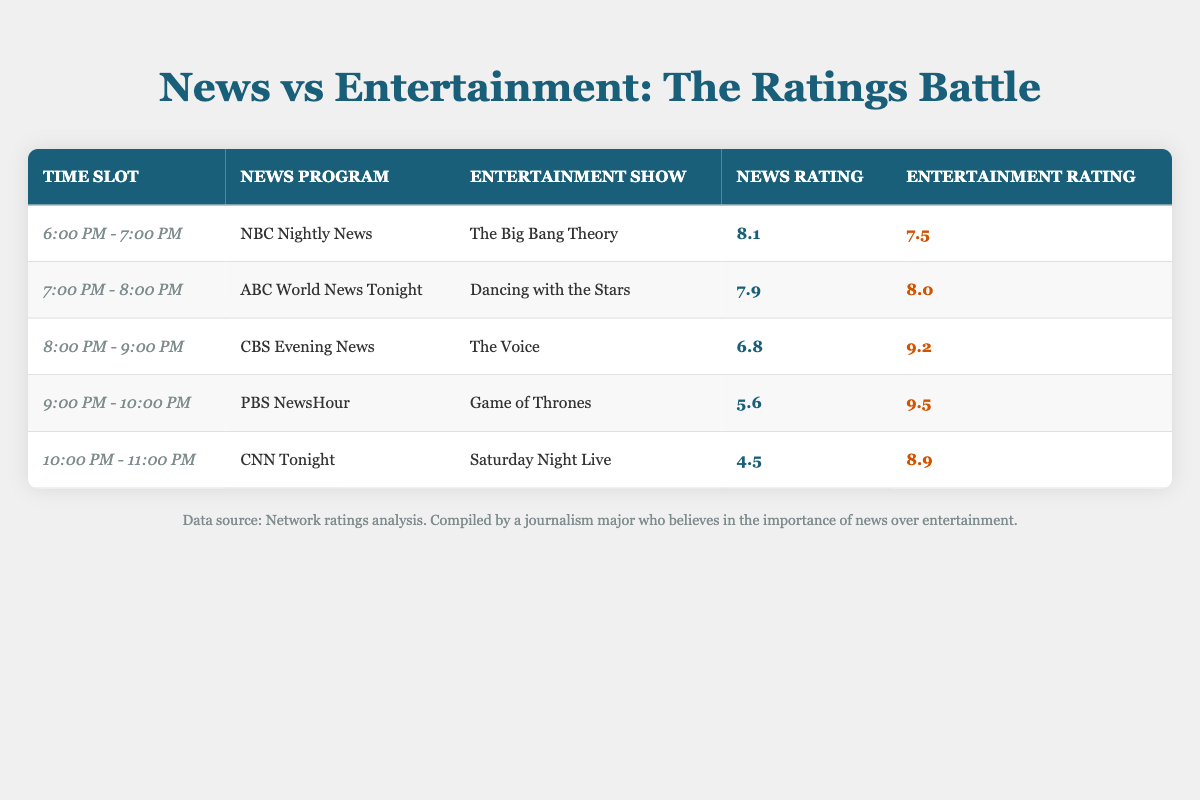What is the news rating for NBC Nightly News? The table shows that the news rating for NBC Nightly News, which airs from 6:00 PM - 7:00 PM, is listed in the corresponding row. I can look directly at the entry for this news program.
Answer: 8.1 Which entertainment show received the highest rating in the 8:00 PM - 9:00 PM time slot? By examining the relevant row for the time slot of 8:00 PM - 9:00 PM, I can see that The Voice has an entertainment rating of 9.2, which is the highest among the shows in that hour.
Answer: The Voice Is the news rating for ABC World News Tonight higher than the entertainment rating for Dancing with the Stars? The table shows ABC World News Tonight with a news rating of 7.9 and Dancing with the Stars with an entertainment rating of 8.0. Since 7.9 is less than 8.0, I can conclude that the news rating is not higher.
Answer: No What is the average rating for news programs across all time slots? To find the average, I need to first sum the news ratings: 8.1 + 7.9 + 6.8 + 5.6 + 4.5 = 33.9. Then, I divide this total by the number of news programs, which is 5. Thus, the average news rating is 33.9 / 5 = 6.78.
Answer: 6.78 Which time slot has the lowest news rating, and what is that rating? By looking through the news ratings in each row, I find that the lowest rating is for CNN Tonight in the time slot of 10:00 PM - 11:00 PM, with a rating of 4.5.
Answer: 10:00 PM - 11:00 PM, 4.5 